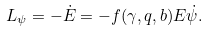<formula> <loc_0><loc_0><loc_500><loc_500>L _ { \psi } = - \dot { E } = - f ( \gamma , q , b ) E \dot { \psi } .</formula> 